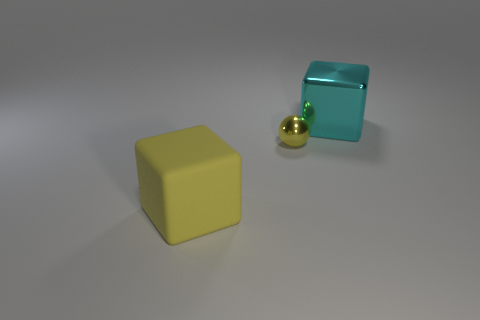Add 1 tiny yellow shiny blocks. How many objects exist? 4 Subtract all spheres. How many objects are left? 2 Add 2 big gray shiny objects. How many big gray shiny objects exist? 2 Subtract 0 green cubes. How many objects are left? 3 Subtract all small yellow spheres. Subtract all tiny shiny objects. How many objects are left? 1 Add 2 large shiny cubes. How many large shiny cubes are left? 3 